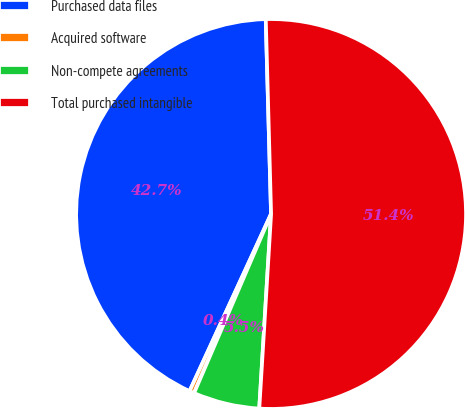Convert chart. <chart><loc_0><loc_0><loc_500><loc_500><pie_chart><fcel>Purchased data files<fcel>Acquired software<fcel>Non-compete agreements<fcel>Total purchased intangible<nl><fcel>42.7%<fcel>0.4%<fcel>5.5%<fcel>51.4%<nl></chart> 